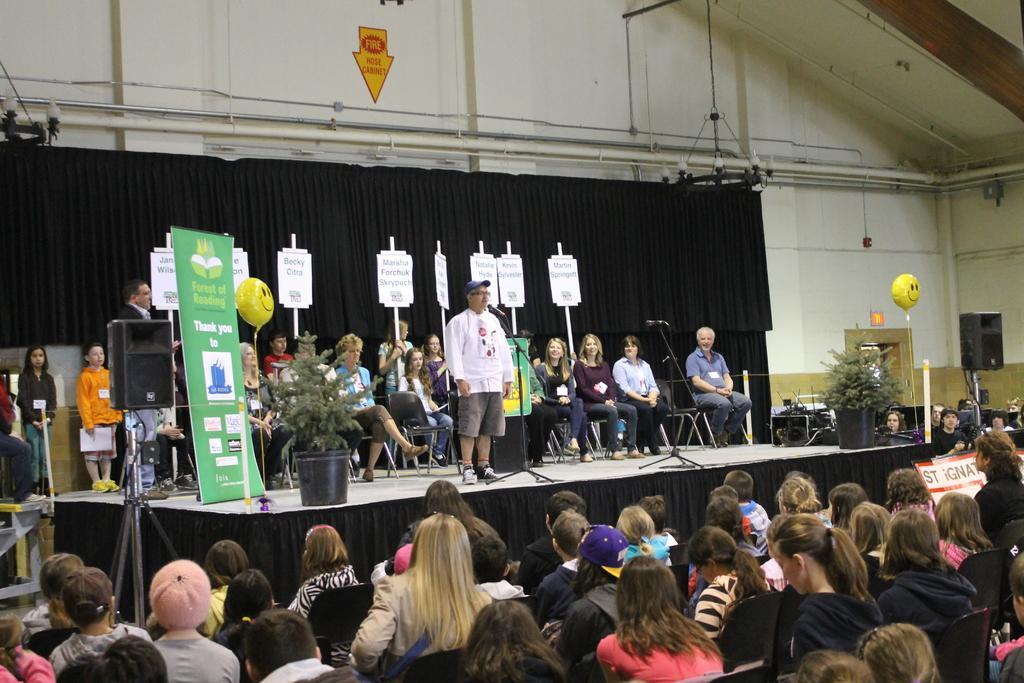Can you describe this image briefly? In the center of the image we can see a man standing. There are mics placed on the stand. In the background there are people sitting and some of them are standing and holding boards. On the left there is a speaker and a banner. At the bottom there is crowd. On the right we can see a flower pot. In the background there is a curtain and a wall. 